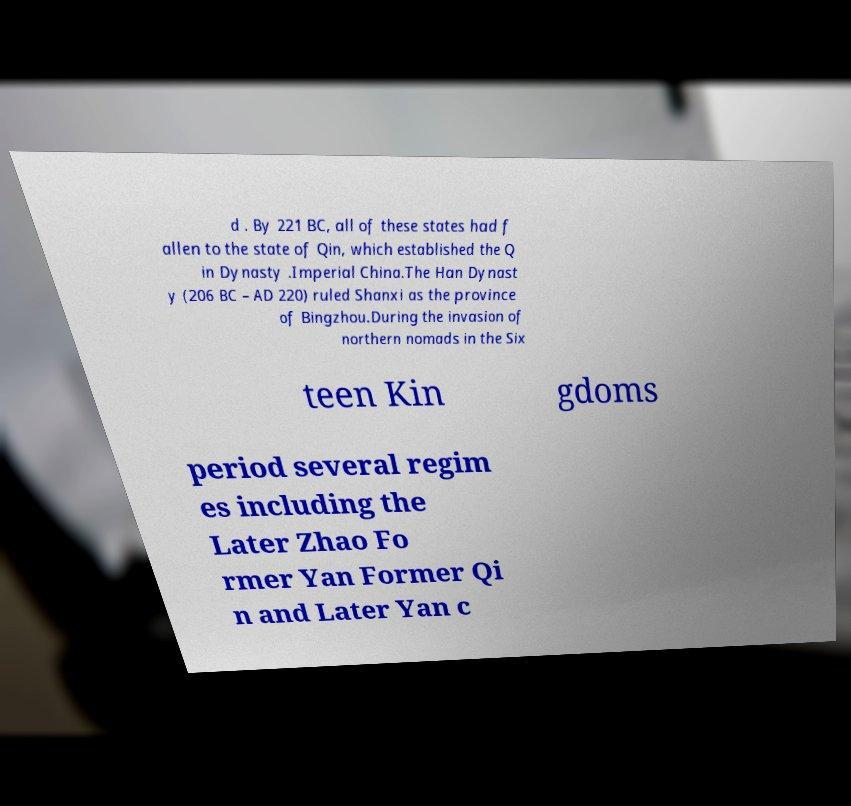Can you read and provide the text displayed in the image?This photo seems to have some interesting text. Can you extract and type it out for me? d . By 221 BC, all of these states had f allen to the state of Qin, which established the Q in Dynasty .Imperial China.The Han Dynast y (206 BC – AD 220) ruled Shanxi as the province of Bingzhou.During the invasion of northern nomads in the Six teen Kin gdoms period several regim es including the Later Zhao Fo rmer Yan Former Qi n and Later Yan c 